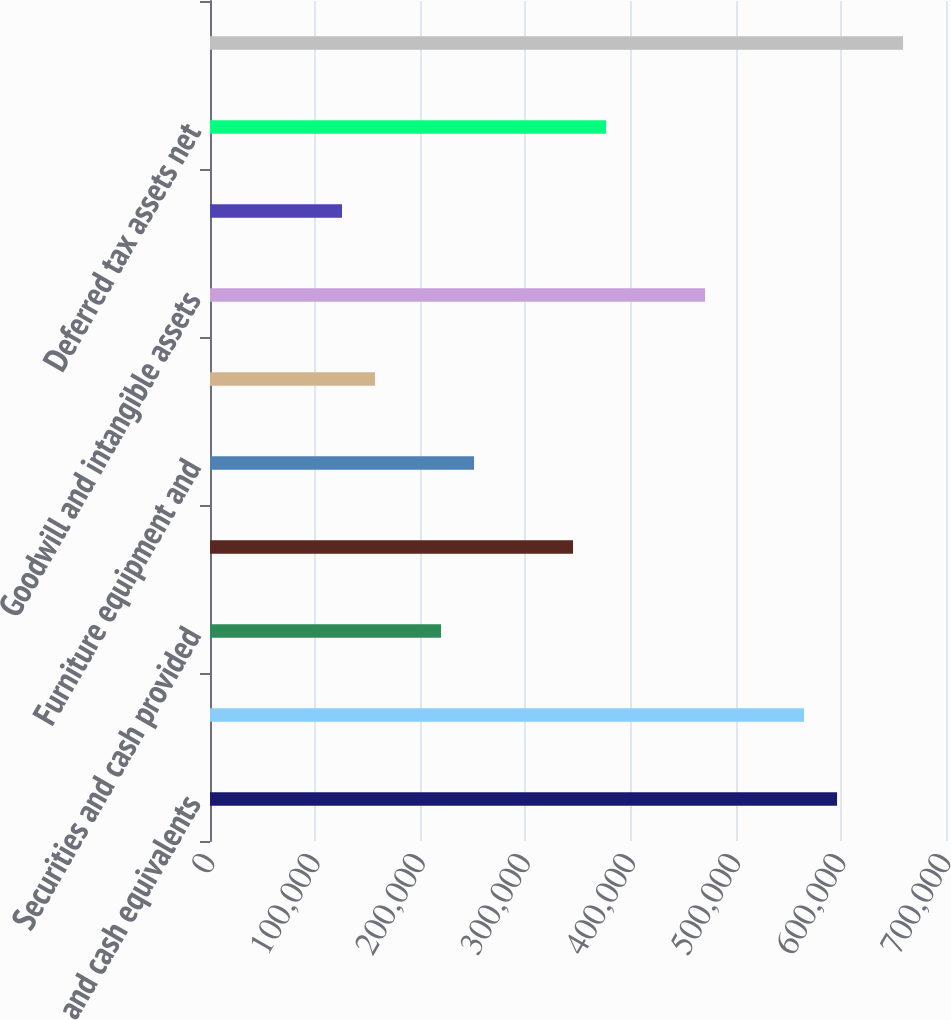<chart> <loc_0><loc_0><loc_500><loc_500><bar_chart><fcel>Cash and cash equivalents<fcel>Securities available-for-sale<fcel>Securities and cash provided<fcel>Accounts receivable including<fcel>Furniture equipment and<fcel>Software development costs net<fcel>Goodwill and intangible assets<fcel>Prepaid expenses and other<fcel>Deferred tax assets net<fcel>Total assets<nl><fcel>596394<fcel>565006<fcel>219730<fcel>345285<fcel>251119<fcel>156952<fcel>470840<fcel>125564<fcel>376673<fcel>659172<nl></chart> 